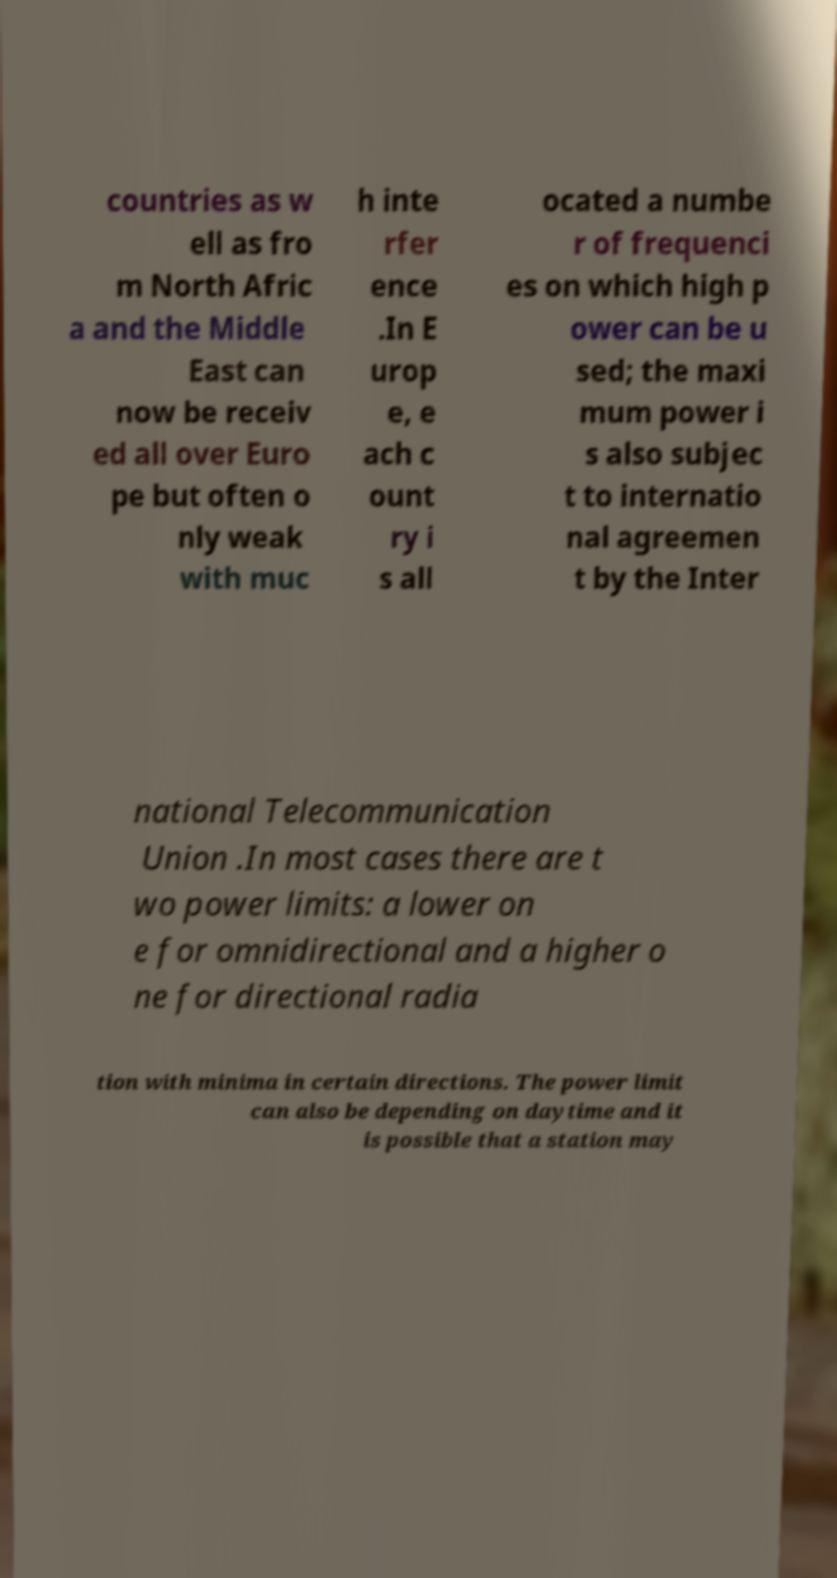Could you assist in decoding the text presented in this image and type it out clearly? countries as w ell as fro m North Afric a and the Middle East can now be receiv ed all over Euro pe but often o nly weak with muc h inte rfer ence .In E urop e, e ach c ount ry i s all ocated a numbe r of frequenci es on which high p ower can be u sed; the maxi mum power i s also subjec t to internatio nal agreemen t by the Inter national Telecommunication Union .In most cases there are t wo power limits: a lower on e for omnidirectional and a higher o ne for directional radia tion with minima in certain directions. The power limit can also be depending on daytime and it is possible that a station may 